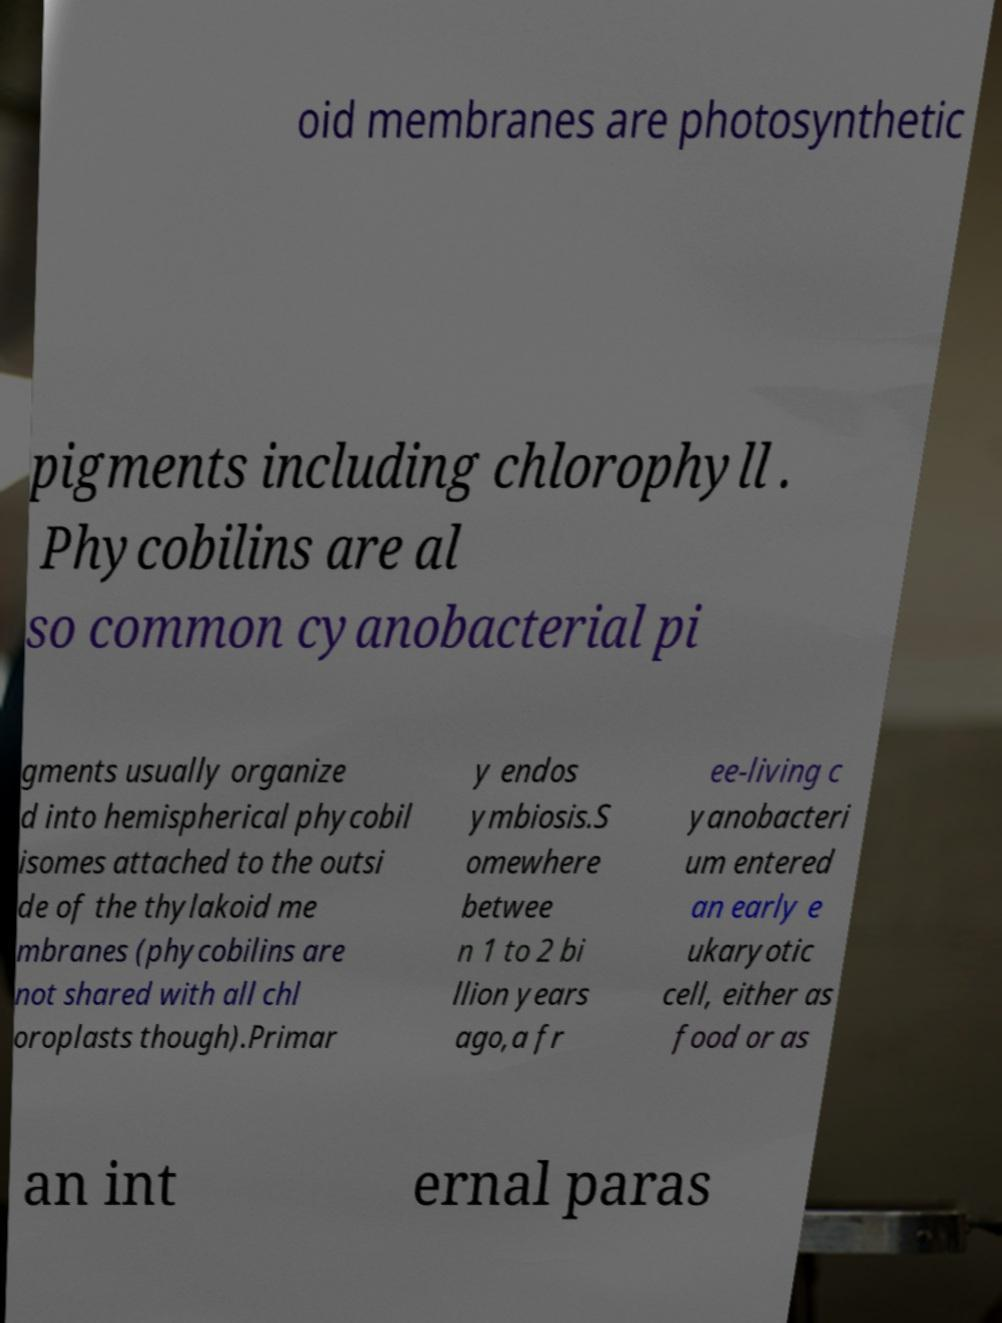There's text embedded in this image that I need extracted. Can you transcribe it verbatim? oid membranes are photosynthetic pigments including chlorophyll . Phycobilins are al so common cyanobacterial pi gments usually organize d into hemispherical phycobil isomes attached to the outsi de of the thylakoid me mbranes (phycobilins are not shared with all chl oroplasts though).Primar y endos ymbiosis.S omewhere betwee n 1 to 2 bi llion years ago,a fr ee-living c yanobacteri um entered an early e ukaryotic cell, either as food or as an int ernal paras 